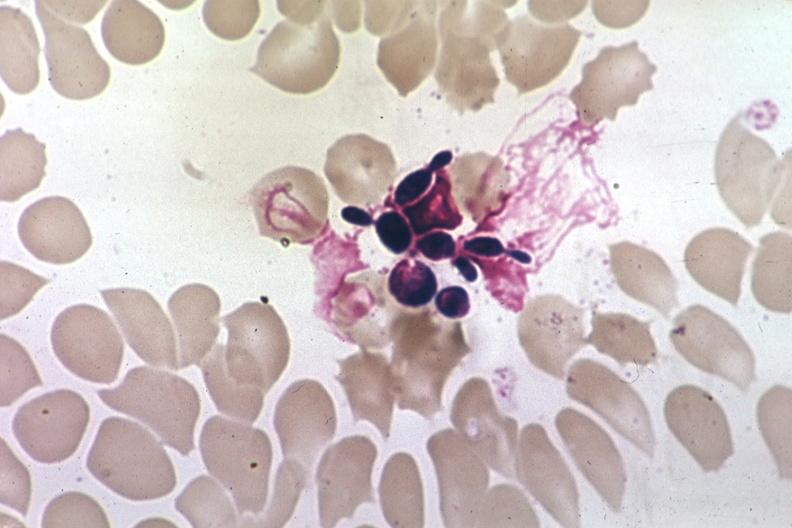s candida in peripheral blood present?
Answer the question using a single word or phrase. Yes 